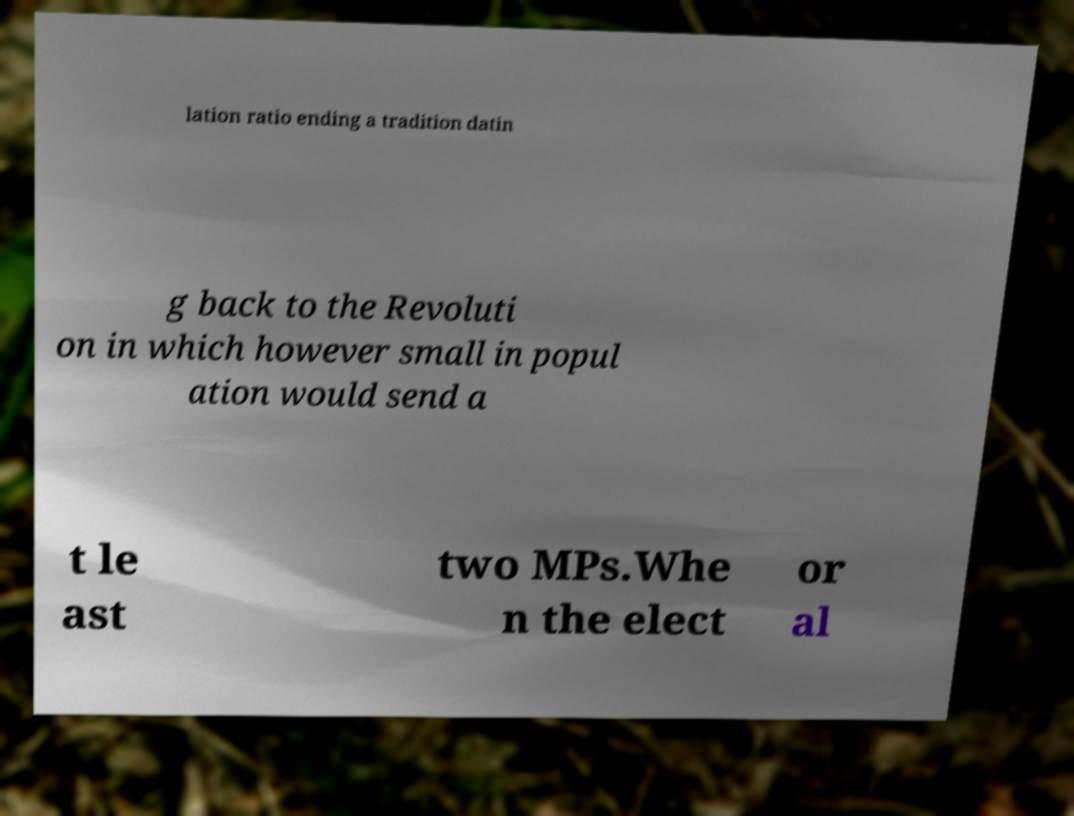Could you extract and type out the text from this image? lation ratio ending a tradition datin g back to the Revoluti on in which however small in popul ation would send a t le ast two MPs.Whe n the elect or al 